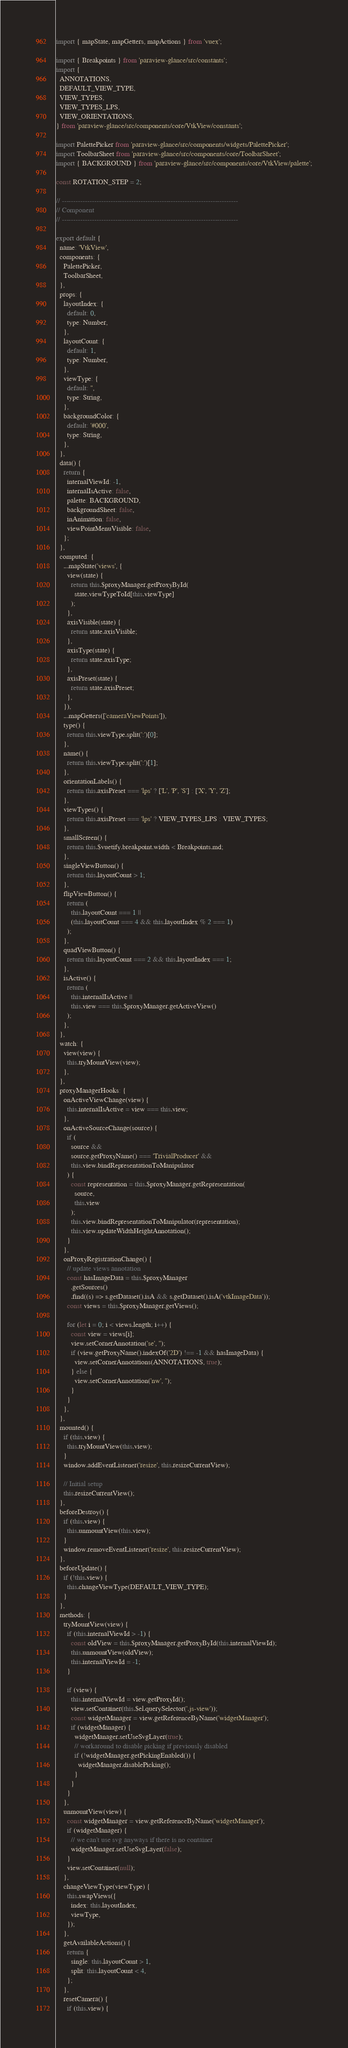<code> <loc_0><loc_0><loc_500><loc_500><_JavaScript_>import { mapState, mapGetters, mapActions } from 'vuex';

import { Breakpoints } from 'paraview-glance/src/constants';
import {
  ANNOTATIONS,
  DEFAULT_VIEW_TYPE,
  VIEW_TYPES,
  VIEW_TYPES_LPS,
  VIEW_ORIENTATIONS,
} from 'paraview-glance/src/components/core/VtkView/constants';

import PalettePicker from 'paraview-glance/src/components/widgets/PalettePicker';
import ToolbarSheet from 'paraview-glance/src/components/core/ToolbarSheet';
import { BACKGROUND } from 'paraview-glance/src/components/core/VtkView/palette';

const ROTATION_STEP = 2;

// ----------------------------------------------------------------------------
// Component
// ----------------------------------------------------------------------------

export default {
  name: 'VtkView',
  components: {
    PalettePicker,
    ToolbarSheet,
  },
  props: {
    layoutIndex: {
      default: 0,
      type: Number,
    },
    layoutCount: {
      default: 1,
      type: Number,
    },
    viewType: {
      default: '',
      type: String,
    },
    backgroundColor: {
      default: '#000',
      type: String,
    },
  },
  data() {
    return {
      internalViewId: -1,
      internalIsActive: false,
      palette: BACKGROUND,
      backgroundSheet: false,
      inAnimation: false,
      viewPointMenuVisible: false,
    };
  },
  computed: {
    ...mapState('views', {
      view(state) {
        return this.$proxyManager.getProxyById(
          state.viewTypeToId[this.viewType]
        );
      },
      axisVisible(state) {
        return state.axisVisible;
      },
      axisType(state) {
        return state.axisType;
      },
      axisPreset(state) {
        return state.axisPreset;
      },
    }),
    ...mapGetters(['cameraViewPoints']),
    type() {
      return this.viewType.split(':')[0];
    },
    name() {
      return this.viewType.split(':')[1];
    },
    orientationLabels() {
      return this.axisPreset === 'lps' ? ['L', 'P', 'S'] : ['X', 'Y', 'Z'];
    },
    viewTypes() {
      return this.axisPreset === 'lps' ? VIEW_TYPES_LPS : VIEW_TYPES;
    },
    smallScreen() {
      return this.$vuetify.breakpoint.width < Breakpoints.md;
    },
    singleViewButton() {
      return this.layoutCount > 1;
    },
    flipViewButton() {
      return (
        this.layoutCount === 1 ||
        (this.layoutCount === 4 && this.layoutIndex % 2 === 1)
      );
    },
    quadViewButton() {
      return this.layoutCount === 2 && this.layoutIndex === 1;
    },
    isActive() {
      return (
        this.internalIsActive ||
        this.view === this.$proxyManager.getActiveView()
      );
    },
  },
  watch: {
    view(view) {
      this.tryMountView(view);
    },
  },
  proxyManagerHooks: {
    onActiveViewChange(view) {
      this.internalIsActive = view === this.view;
    },
    onActiveSourceChange(source) {
      if (
        source &&
        source.getProxyName() === 'TrivialProducer' &&
        this.view.bindRepresentationToManipulator
      ) {
        const representation = this.$proxyManager.getRepresentation(
          source,
          this.view
        );
        this.view.bindRepresentationToManipulator(representation);
        this.view.updateWidthHeightAnnotation();
      }
    },
    onProxyRegistrationChange() {
      // update views annotation
      const hasImageData = this.$proxyManager
        .getSources()
        .find((s) => s.getDataset().isA && s.getDataset().isA('vtkImageData'));
      const views = this.$proxyManager.getViews();

      for (let i = 0; i < views.length; i++) {
        const view = views[i];
        view.setCornerAnnotation('se', '');
        if (view.getProxyName().indexOf('2D') !== -1 && hasImageData) {
          view.setCornerAnnotations(ANNOTATIONS, true);
        } else {
          view.setCornerAnnotation('nw', '');
        }
      }
    },
  },
  mounted() {
    if (this.view) {
      this.tryMountView(this.view);
    }
    window.addEventListener('resize', this.resizeCurrentView);

    // Initial setup
    this.resizeCurrentView();
  },
  beforeDestroy() {
    if (this.view) {
      this.unmountView(this.view);
    }
    window.removeEventListener('resize', this.resizeCurrentView);
  },
  beforeUpdate() {
    if (!this.view) {
      this.changeViewType(DEFAULT_VIEW_TYPE);
    }
  },
  methods: {
    tryMountView(view) {
      if (this.internalViewId > -1) {
        const oldView = this.$proxyManager.getProxyById(this.internalViewId);
        this.unmountView(oldView);
        this.internalViewId = -1;
      }

      if (view) {
        this.internalViewId = view.getProxyId();
        view.setContainer(this.$el.querySelector('.js-view'));
        const widgetManager = view.getReferenceByName('widgetManager');
        if (widgetManager) {
          widgetManager.setUseSvgLayer(true);
          // workaround to disable picking if previously disabled
          if (!widgetManager.getPickingEnabled()) {
            widgetManager.disablePicking();
          }
        }
      }
    },
    unmountView(view) {
      const widgetManager = view.getReferenceByName('widgetManager');
      if (widgetManager) {
        // we can't use svg anyways if there is no container
        widgetManager.setUseSvgLayer(false);
      }
      view.setContainer(null);
    },
    changeViewType(viewType) {
      this.swapViews({
        index: this.layoutIndex,
        viewType,
      });
    },
    getAvailableActions() {
      return {
        single: this.layoutCount > 1,
        split: this.layoutCount < 4,
      };
    },
    resetCamera() {
      if (this.view) {</code> 